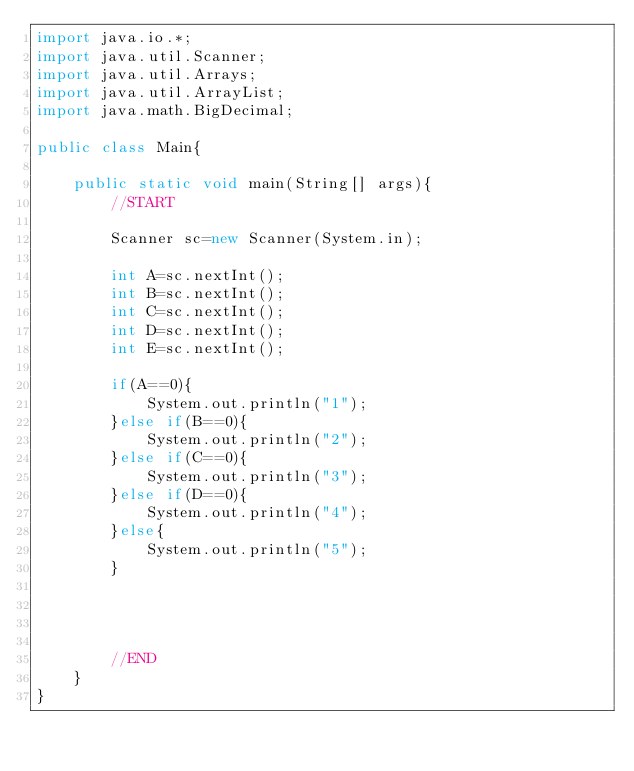<code> <loc_0><loc_0><loc_500><loc_500><_Java_>import java.io.*;
import java.util.Scanner;
import java.util.Arrays;
import java.util.ArrayList;
import java.math.BigDecimal;

public class Main{

    public static void main(String[] args){
        //START

        Scanner sc=new Scanner(System.in);

        int A=sc.nextInt();
        int B=sc.nextInt();
        int C=sc.nextInt();
        int D=sc.nextInt();
        int E=sc.nextInt();

        if(A==0){
            System.out.println("1");
        }else if(B==0){
            System.out.println("2");
        }else if(C==0){
            System.out.println("3");
        }else if(D==0){
            System.out.println("4");
        }else{
            System.out.println("5");
        }




        //END
    }
}


</code> 